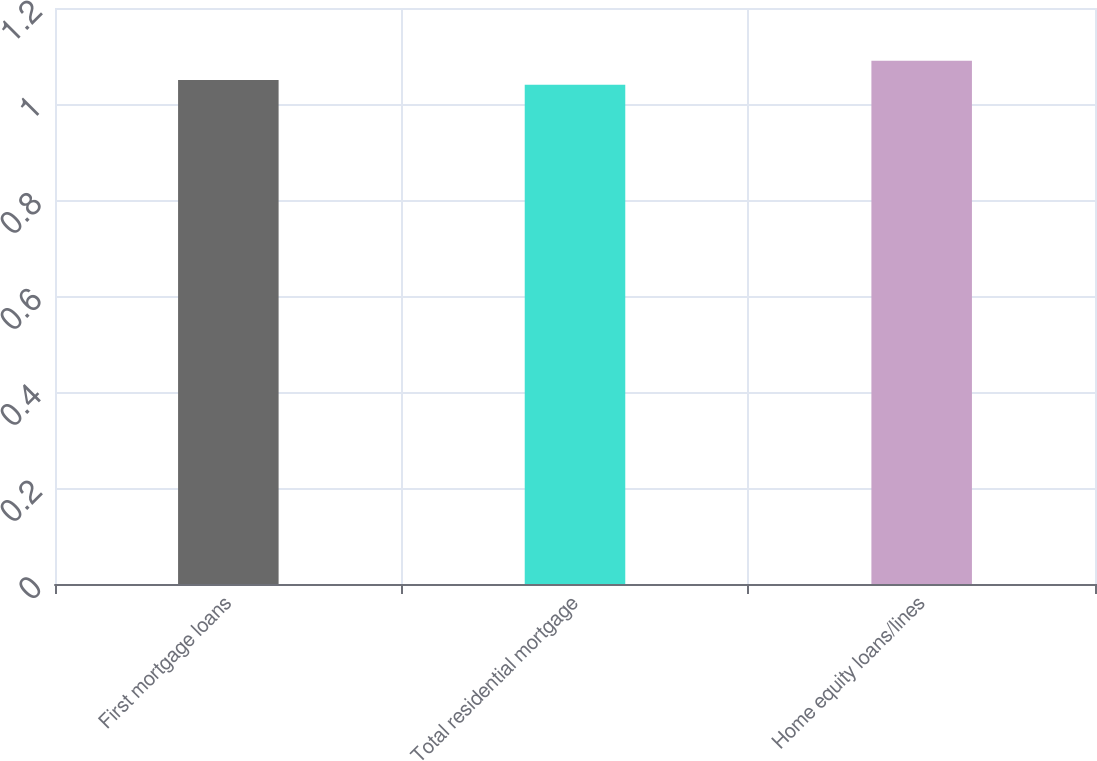Convert chart to OTSL. <chart><loc_0><loc_0><loc_500><loc_500><bar_chart><fcel>First mortgage loans<fcel>Total residential mortgage<fcel>Home equity loans/lines<nl><fcel>1.05<fcel>1.04<fcel>1.09<nl></chart> 